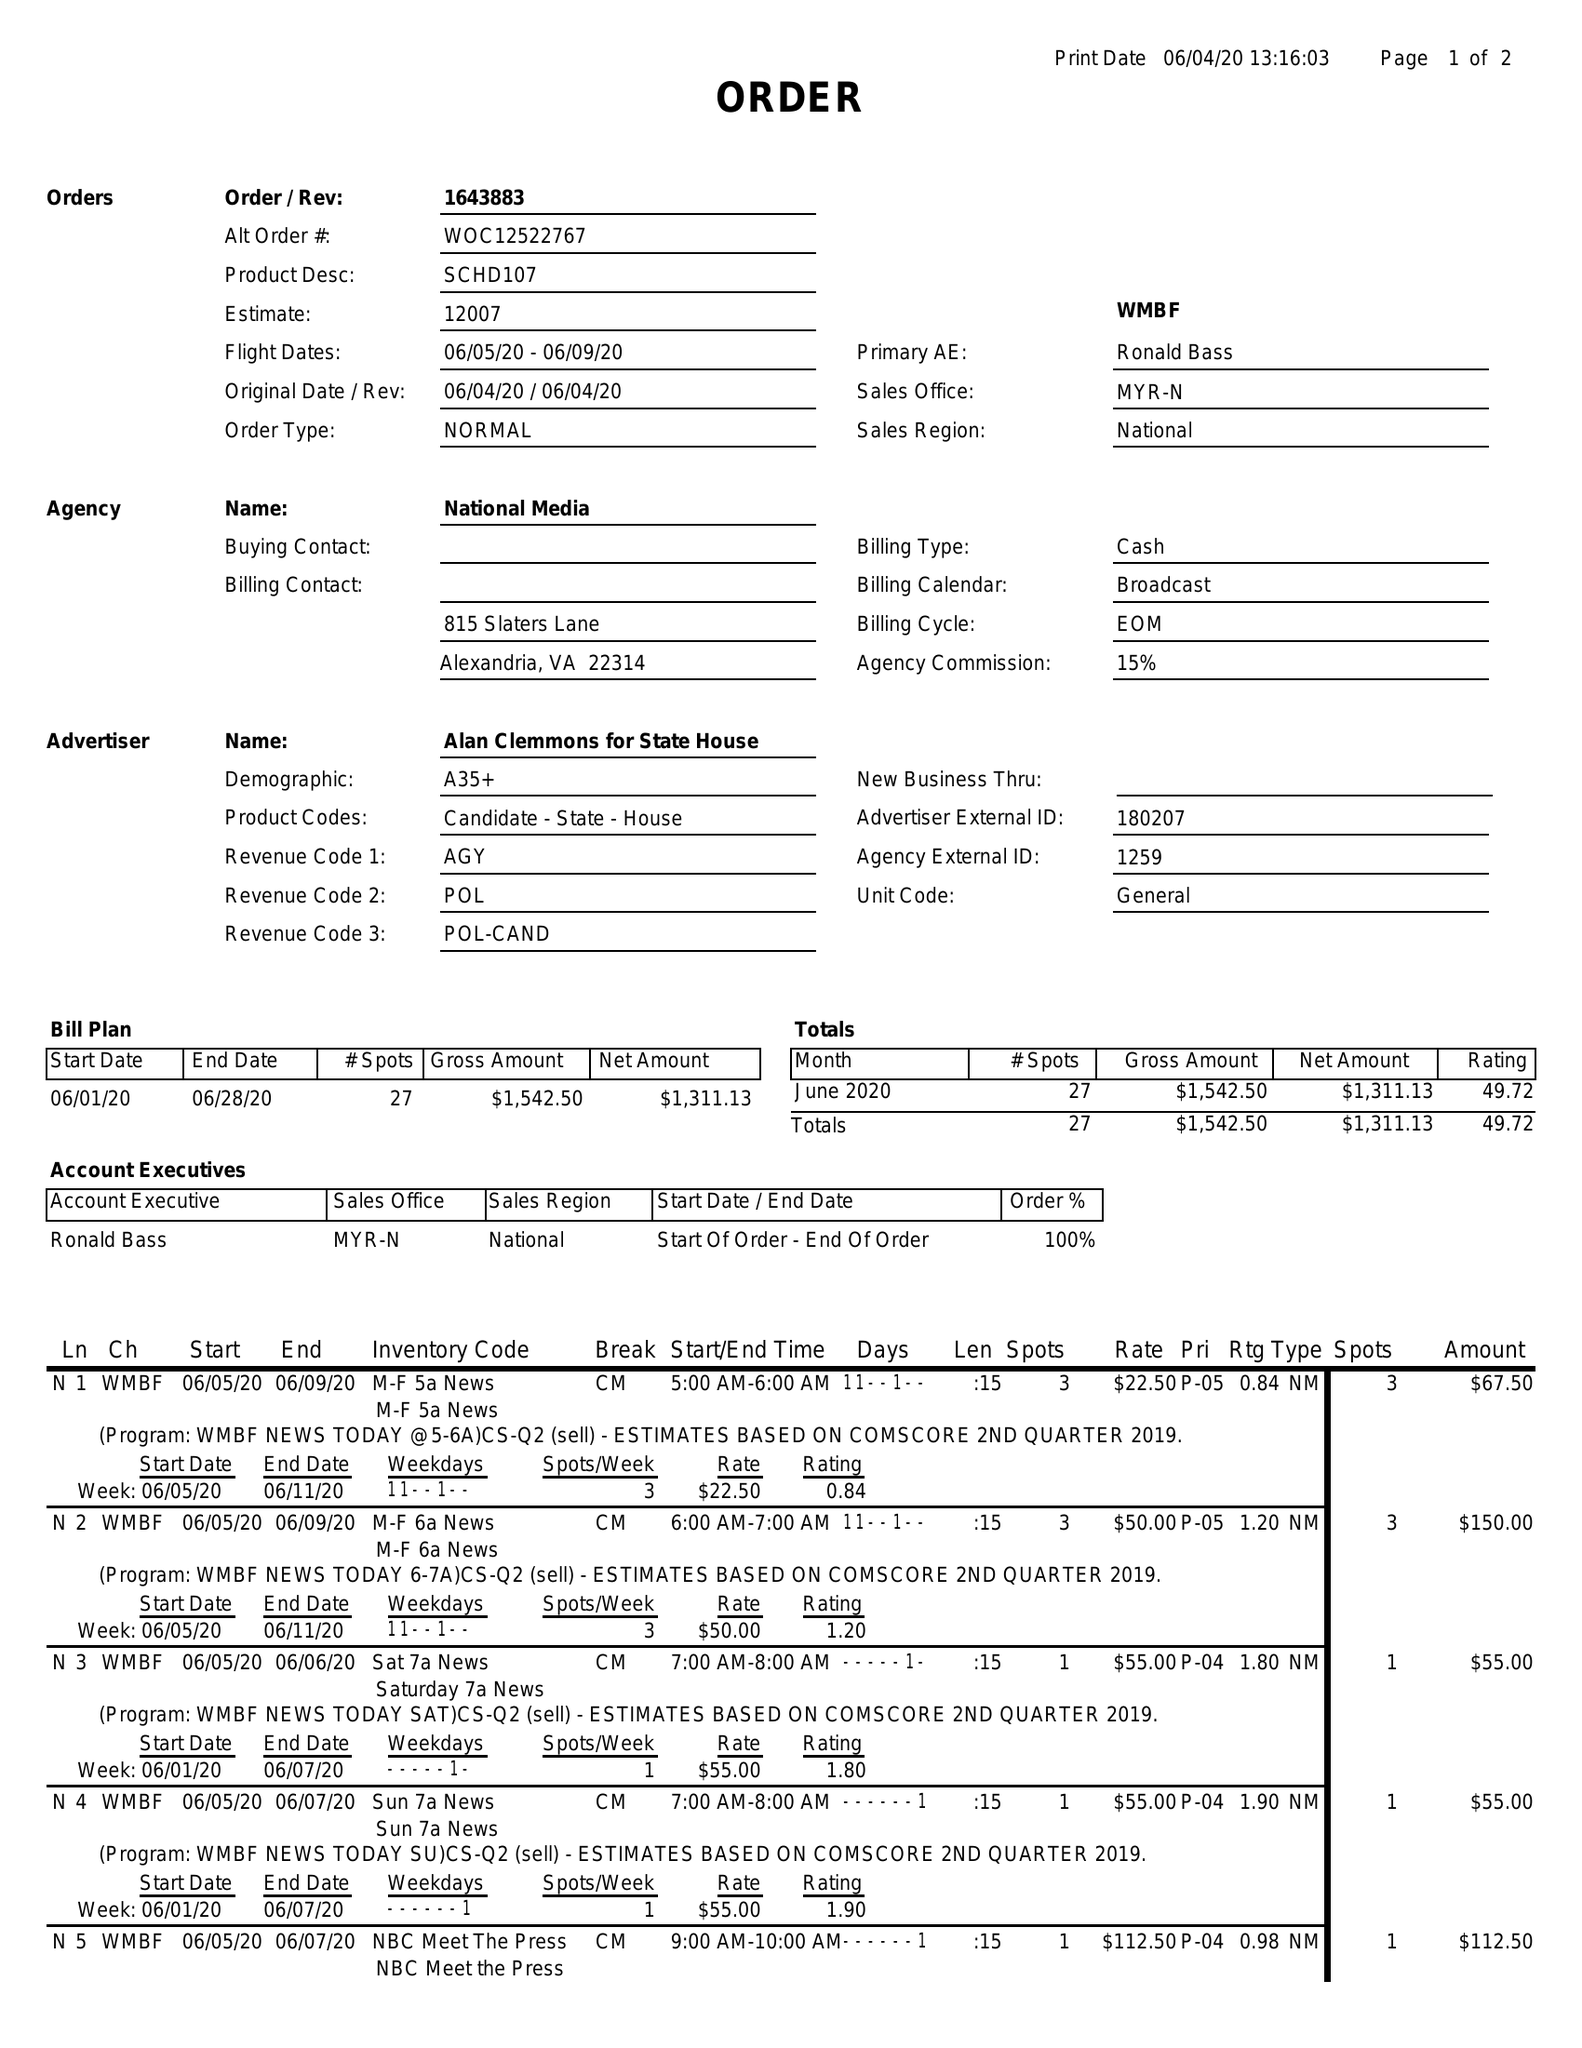What is the value for the gross_amount?
Answer the question using a single word or phrase. 1542.50 